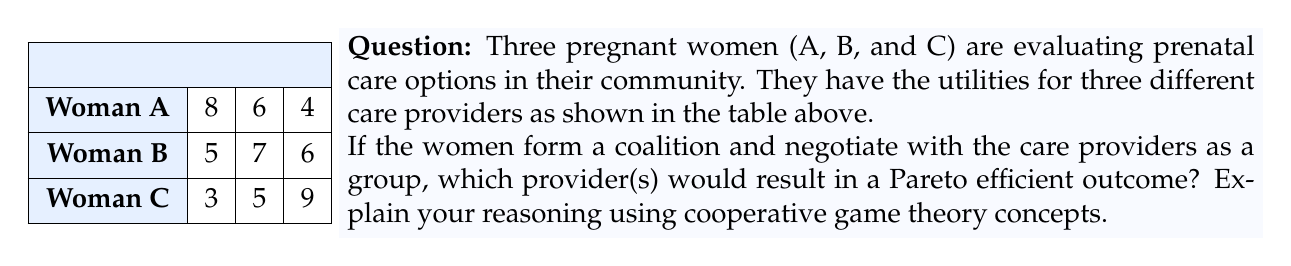Help me with this question. To determine the Pareto efficient outcome(s), we need to analyze the total utility for each provider and consider if any allocation can be improved without making at least one woman worse off.

Step 1: Calculate the total utility for each provider.
Provider 1: $8 + 5 + 3 = 16$
Provider 2: $6 + 7 + 5 = 18$
Provider 3: $4 + 6 + 9 = 19$

Step 2: Analyze Pareto efficiency.

Provider 1 is not Pareto efficient because moving to either Provider 2 or Provider 3 would increase the total utility without making all women worse off.

Provider 2 is Pareto efficient because:
- Moving to Provider 1 would make B and C worse off
- Moving to Provider 3 would make A and B worse off

Provider 3 is Pareto efficient because:
- Moving to Provider 1 would make B and C worse off
- Moving to Provider 2 would make A and C worse off

Step 3: Consider coalition formation.
In cooperative game theory, the women can form a coalition to negotiate with providers. They would likely choose between Provider 2 and Provider 3, as these are the Pareto efficient options.

The choice between Provider 2 and Provider 3 would depend on how the coalition decides to distribute the utility gain. This could involve side payments or other negotiations within the group.

Step 4: Apply the core concept.
Both Provider 2 and Provider 3 are in the core of this cooperative game, as no subcoalition can do better by deviating from these choices.
Answer: Providers 2 and 3 are Pareto efficient. 